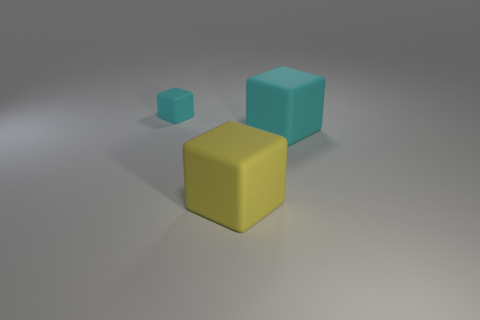Add 3 large matte cubes. How many objects exist? 6 Subtract all tiny cyan matte things. Subtract all big red blocks. How many objects are left? 2 Add 3 large cyan rubber objects. How many large cyan rubber objects are left? 4 Add 3 big cyan matte cubes. How many big cyan matte cubes exist? 4 Subtract 0 brown balls. How many objects are left? 3 